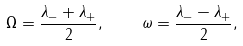<formula> <loc_0><loc_0><loc_500><loc_500>\Omega = \frac { \lambda _ { - } + \lambda _ { + } } { 2 } , \quad \omega = \frac { \lambda _ { - } - \lambda _ { + } } { 2 } ,</formula> 